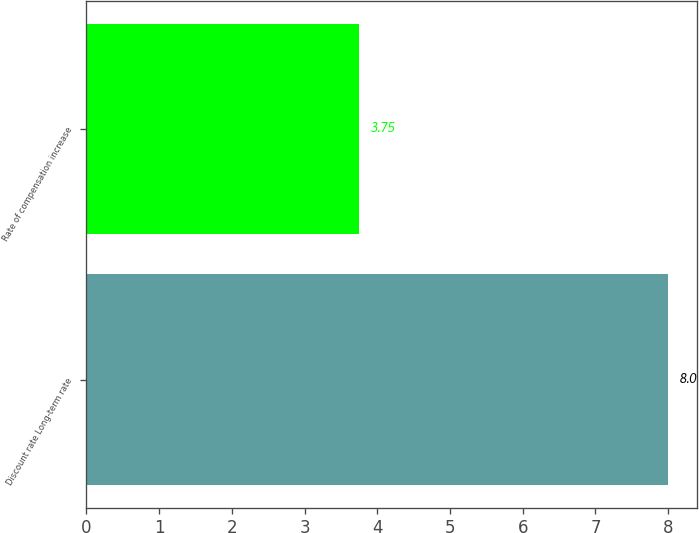Convert chart to OTSL. <chart><loc_0><loc_0><loc_500><loc_500><bar_chart><fcel>Discount rate Long-term rate<fcel>Rate of compensation increase<nl><fcel>8<fcel>3.75<nl></chart> 